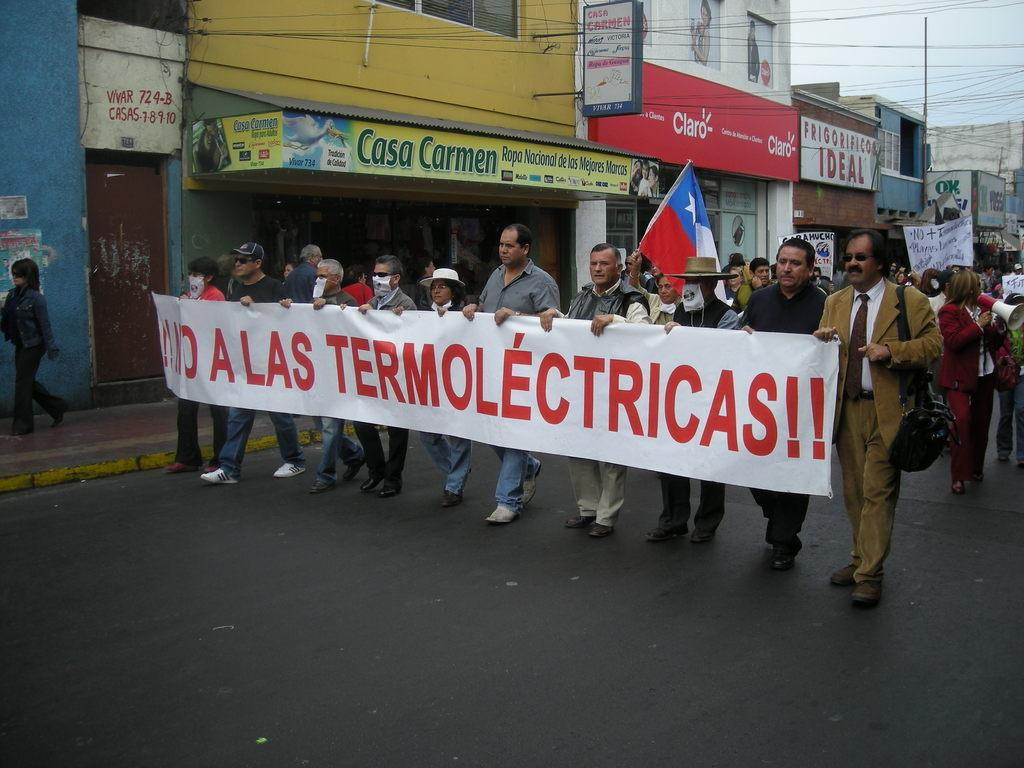How many people can be seen in the image? There are many people in the image. What are the people doing in the image? The people are walking. What can be seen hanging in the image? There are banners, placards, and flags in the image. What type of structures can be seen in the background of the image? There are shops and buildings in the background of the image. What is at the bottom of the image? There is a road at the bottom of the image. Where is the hose being used in the image? There is no hose present in the image. What type of thrill can be experienced by the people in the image? The image does not depict any specific thrilling activity; the people are simply walking. 